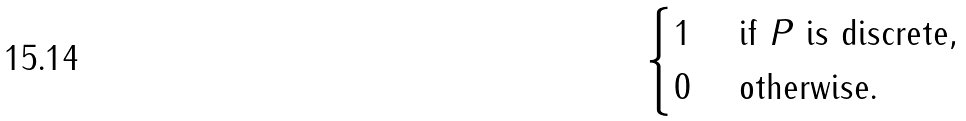<formula> <loc_0><loc_0><loc_500><loc_500>\begin{cases} 1 & \text { if $P$ is discrete} , \\ 0 & \text { otherwise.} \end{cases}</formula> 